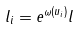<formula> <loc_0><loc_0><loc_500><loc_500>l _ { i } = e ^ { \omega ( u _ { i } ) } l</formula> 